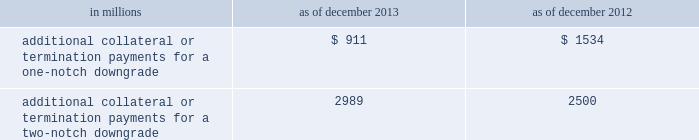Management 2019s discussion and analysis we believe our credit ratings are primarily based on the credit rating agencies 2019 assessment of : 2030 our liquidity , market , credit and operational risk management practices ; 2030 the level and variability of our earnings ; 2030 our capital base ; 2030 our franchise , reputation and management ; 2030 our corporate governance ; and 2030 the external operating environment , including the assumed level of government support .
Certain of the firm 2019s derivatives have been transacted under bilateral agreements with counterparties who may require us to post collateral or terminate the transactions based on changes in our credit ratings .
We assess the impact of these bilateral agreements by determining the collateral or termination payments that would occur assuming a downgrade by all rating agencies .
A downgrade by any one rating agency , depending on the agency 2019s relative ratings of the firm at the time of the downgrade , may have an impact which is comparable to the impact of a downgrade by all rating agencies .
We allocate a portion of our gce to ensure we would be able to make the additional collateral or termination payments that may be required in the event of a two-notch reduction in our long-term credit ratings , as well as collateral that has not been called by counterparties , but is available to them .
The table below presents the additional collateral or termination payments related to our net derivative liabilities under bilateral agreements that could have been called at the reporting date by counterparties in the event of a one-notch and two-notch downgrade in our credit ratings. .
In millions 2013 2012 additional collateral or termination payments for a one-notch downgrade $ 911 $ 1534 additional collateral or termination payments for a two-notch downgrade 2989 2500 cash flows as a global financial institution , our cash flows are complex and bear little relation to our net earnings and net assets .
Consequently , we believe that traditional cash flow analysis is less meaningful in evaluating our liquidity position than the excess liquidity and asset-liability management policies described above .
Cash flow analysis may , however , be helpful in highlighting certain macro trends and strategic initiatives in our businesses .
Year ended december 2013 .
Our cash and cash equivalents decreased by $ 11.54 billion to $ 61.13 billion at the end of 2013 .
We generated $ 4.54 billion in net cash from operating activities .
We used net cash of $ 16.08 billion for investing and financing activities , primarily to fund loans held for investment and repurchases of common stock .
Year ended december 2012 .
Our cash and cash equivalents increased by $ 16.66 billion to $ 72.67 billion at the end of 2012 .
We generated $ 9.14 billion in net cash from operating and investing activities .
We generated $ 7.52 billion in net cash from financing activities from an increase in bank deposits , partially offset by net repayments of unsecured and secured long-term borrowings .
Year ended december 2011 .
Our cash and cash equivalents increased by $ 16.22 billion to $ 56.01 billion at the end of 2011 .
We generated $ 23.13 billion in net cash from operating and investing activities .
We used net cash of $ 6.91 billion for financing activities , primarily for repurchases of our series g preferred stock and common stock , partially offset by an increase in bank deposits .
Goldman sachs 2013 annual report 89 .
In millions for 2013 and 2012 , what was the total amount of additional collateral or termination payments for a one-notch downgrade? 
Computations: (911 + 1534)
Answer: 2445.0. 